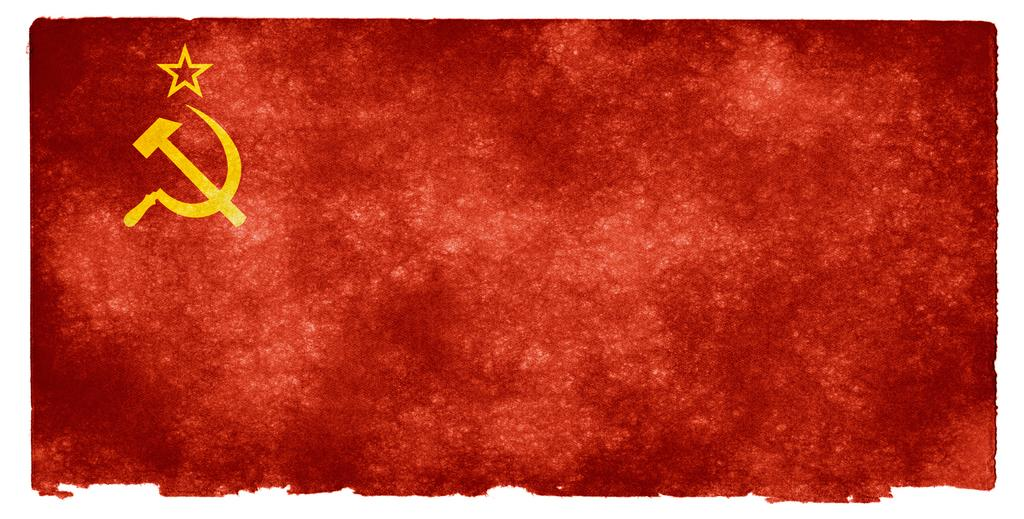What is the dominant color of the painting in the image? The dominant color of the painting in the image is red. Can you describe any specific features or elements on the painting? Yes, there is a symbol on the left side of the painting. What type of yam is being used as a bat in the baseball game depicted in the image? There is no baseball game or yam present in the image; it features a red color painting with a symbol on the left side. 